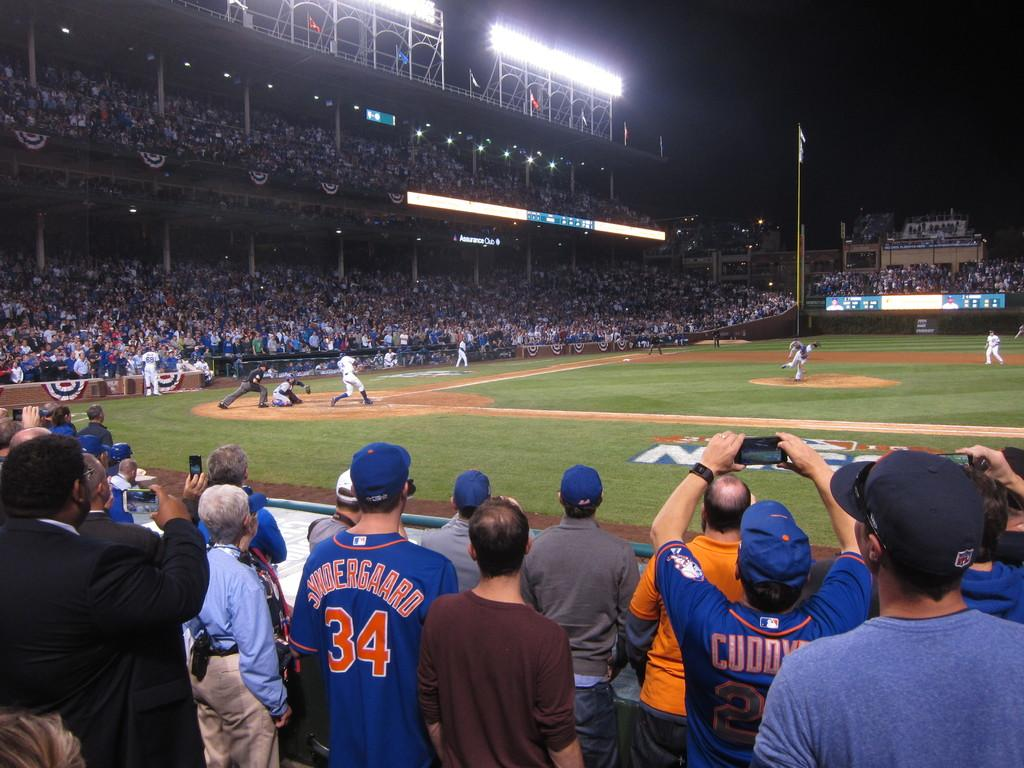<image>
Render a clear and concise summary of the photo. A fan watching a baseball game has a jersey with the number 34 on the back. 